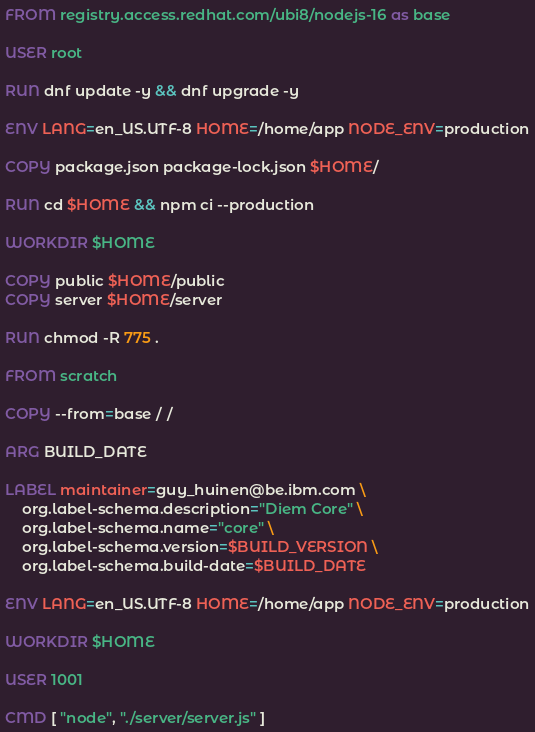Convert code to text. <code><loc_0><loc_0><loc_500><loc_500><_Dockerfile_>FROM registry.access.redhat.com/ubi8/nodejs-16 as base

USER root

RUN dnf update -y && dnf upgrade -y

ENV LANG=en_US.UTF-8 HOME=/home/app NODE_ENV=production

COPY package.json package-lock.json $HOME/

RUN cd $HOME && npm ci --production

WORKDIR $HOME

COPY public $HOME/public
COPY server $HOME/server

RUN chmod -R 775 .

FROM scratch

COPY --from=base / /

ARG BUILD_DATE

LABEL maintainer=guy_huinen@be.ibm.com \
    org.label-schema.description="Diem Core" \
    org.label-schema.name="core" \
    org.label-schema.version=$BUILD_VERSION \
    org.label-schema.build-date=$BUILD_DATE

ENV LANG=en_US.UTF-8 HOME=/home/app NODE_ENV=production

WORKDIR $HOME

USER 1001

CMD [ "node", "./server/server.js" ]</code> 